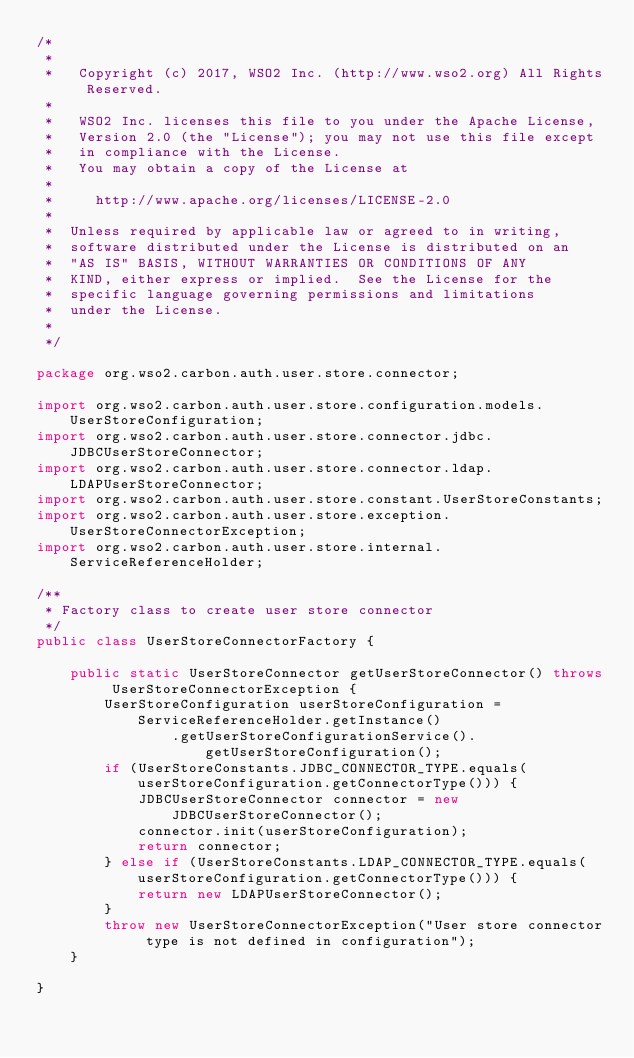Convert code to text. <code><loc_0><loc_0><loc_500><loc_500><_Java_>/*
 *
 *   Copyright (c) 2017, WSO2 Inc. (http://www.wso2.org) All Rights Reserved.
 *
 *   WSO2 Inc. licenses this file to you under the Apache License,
 *   Version 2.0 (the "License"); you may not use this file except
 *   in compliance with the License.
 *   You may obtain a copy of the License at
 *
 *     http://www.apache.org/licenses/LICENSE-2.0
 *
 *  Unless required by applicable law or agreed to in writing,
 *  software distributed under the License is distributed on an
 *  "AS IS" BASIS, WITHOUT WARRANTIES OR CONDITIONS OF ANY
 *  KIND, either express or implied.  See the License for the
 *  specific language governing permissions and limitations
 *  under the License.
 *
 */

package org.wso2.carbon.auth.user.store.connector;

import org.wso2.carbon.auth.user.store.configuration.models.UserStoreConfiguration;
import org.wso2.carbon.auth.user.store.connector.jdbc.JDBCUserStoreConnector;
import org.wso2.carbon.auth.user.store.connector.ldap.LDAPUserStoreConnector;
import org.wso2.carbon.auth.user.store.constant.UserStoreConstants;
import org.wso2.carbon.auth.user.store.exception.UserStoreConnectorException;
import org.wso2.carbon.auth.user.store.internal.ServiceReferenceHolder;

/**
 * Factory class to create user store connector
 */
public class UserStoreConnectorFactory {

    public static UserStoreConnector getUserStoreConnector() throws UserStoreConnectorException {
        UserStoreConfiguration userStoreConfiguration = ServiceReferenceHolder.getInstance()
                .getUserStoreConfigurationService().getUserStoreConfiguration();
        if (UserStoreConstants.JDBC_CONNECTOR_TYPE.equals(userStoreConfiguration.getConnectorType())) {
            JDBCUserStoreConnector connector = new JDBCUserStoreConnector();
            connector.init(userStoreConfiguration);
            return connector;
        } else if (UserStoreConstants.LDAP_CONNECTOR_TYPE.equals(userStoreConfiguration.getConnectorType())) {
            return new LDAPUserStoreConnector();
        }
        throw new UserStoreConnectorException("User store connector type is not defined in configuration");
    }

}
</code> 